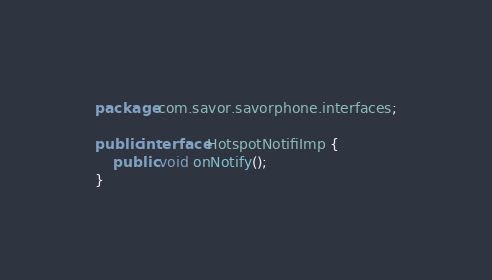<code> <loc_0><loc_0><loc_500><loc_500><_Java_>package com.savor.savorphone.interfaces;

public interface HotspotNotifiImp {
	public void onNotify();
}
</code> 